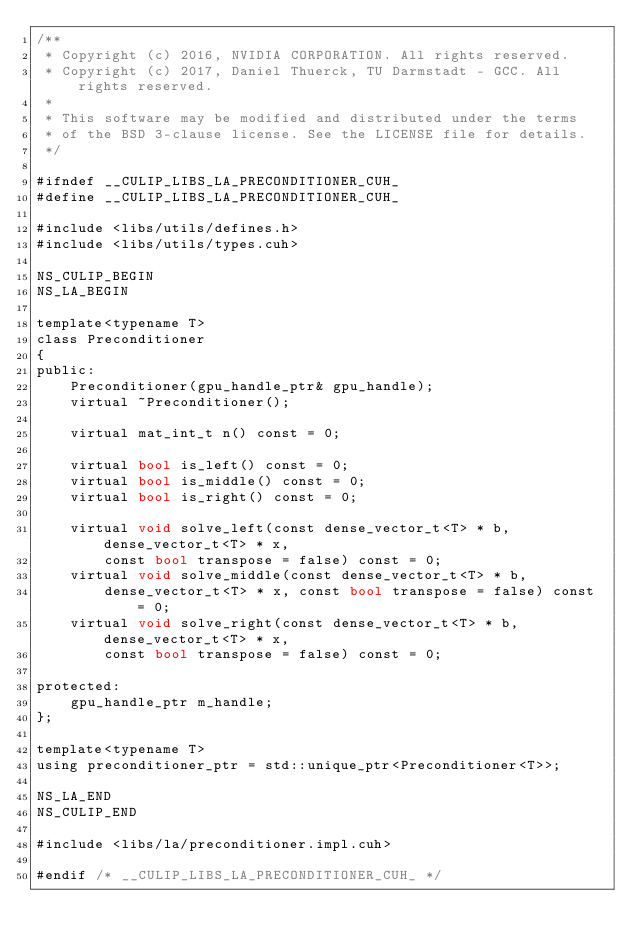Convert code to text. <code><loc_0><loc_0><loc_500><loc_500><_Cuda_>/**
 * Copyright (c) 2016, NVIDIA CORPORATION. All rights reserved.
 * Copyright (c) 2017, Daniel Thuerck, TU Darmstadt - GCC. All rights reserved.
 *
 * This software may be modified and distributed under the terms
 * of the BSD 3-clause license. See the LICENSE file for details.
 */

#ifndef __CULIP_LIBS_LA_PRECONDITIONER_CUH_
#define __CULIP_LIBS_LA_PRECONDITIONER_CUH_

#include <libs/utils/defines.h>
#include <libs/utils/types.cuh>

NS_CULIP_BEGIN
NS_LA_BEGIN

template<typename T>
class Preconditioner
{
public:
    Preconditioner(gpu_handle_ptr& gpu_handle);
    virtual ~Preconditioner();

    virtual mat_int_t n() const = 0;

    virtual bool is_left() const = 0;
    virtual bool is_middle() const = 0;
    virtual bool is_right() const = 0;

    virtual void solve_left(const dense_vector_t<T> * b, dense_vector_t<T> * x,
        const bool transpose = false) const = 0;
    virtual void solve_middle(const dense_vector_t<T> * b,
        dense_vector_t<T> * x, const bool transpose = false) const = 0;
    virtual void solve_right(const dense_vector_t<T> * b, dense_vector_t<T> * x,
        const bool transpose = false) const = 0;

protected:
    gpu_handle_ptr m_handle;
};

template<typename T>
using preconditioner_ptr = std::unique_ptr<Preconditioner<T>>;

NS_LA_END
NS_CULIP_END

#include <libs/la/preconditioner.impl.cuh>

#endif /* __CULIP_LIBS_LA_PRECONDITIONER_CUH_ */
</code> 